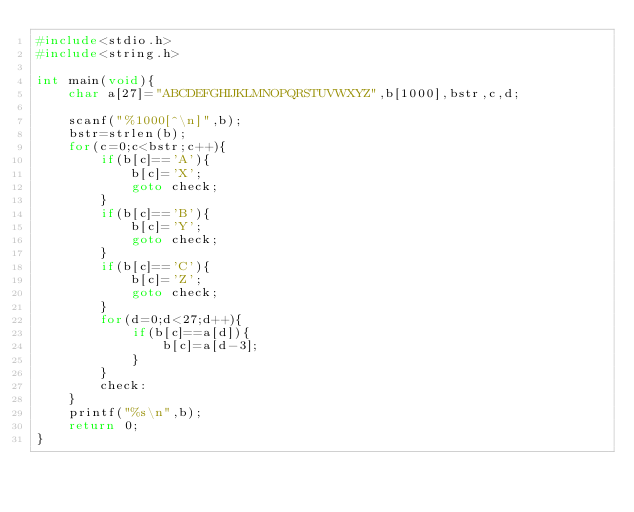<code> <loc_0><loc_0><loc_500><loc_500><_C_>#include<stdio.h>
#include<string.h>

int main(void){   
	char a[27]="ABCDEFGHIJKLMNOPQRSTUVWXYZ",b[1000],bstr,c,d;
	
	scanf("%1000[^\n]",b);
	bstr=strlen(b);
	for(c=0;c<bstr;c++){
		if(b[c]=='A'){
			b[c]='X';
			goto check;
		}
		if(b[c]=='B'){
			b[c]='Y';
			goto check;
		}
		if(b[c]=='C'){
			b[c]='Z';
			goto check;
		}
		for(d=0;d<27;d++){
			if(b[c]==a[d]){	
				b[c]=a[d-3];	
			}
		}
		check:
	}	
	printf("%s\n",b);
	return 0;
}</code> 